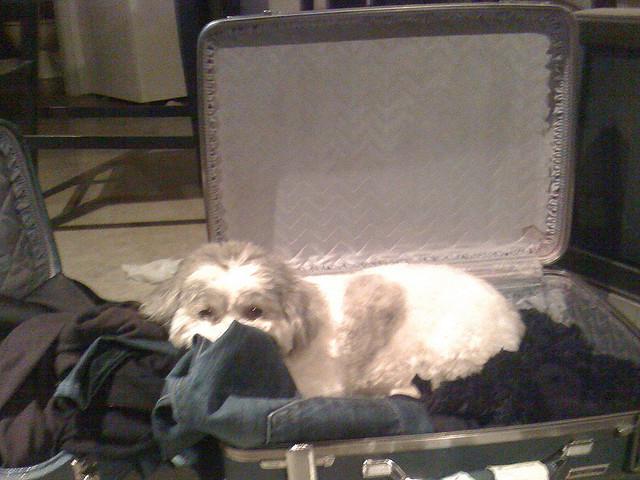Do you see a dog?
Be succinct. Yes. What clothing item is the dog laying on?
Keep it brief. Jeans. Is the dog happy?
Keep it brief. Yes. Is this dog in a rocking chair?
Keep it brief. No. What is this dog name?
Quick response, please. Dog. 